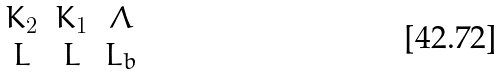Convert formula to latex. <formula><loc_0><loc_0><loc_500><loc_500>\begin{matrix} K _ { 2 } & K _ { 1 } & \Lambda \\ L & L & L _ { b } \\ \end{matrix}</formula> 